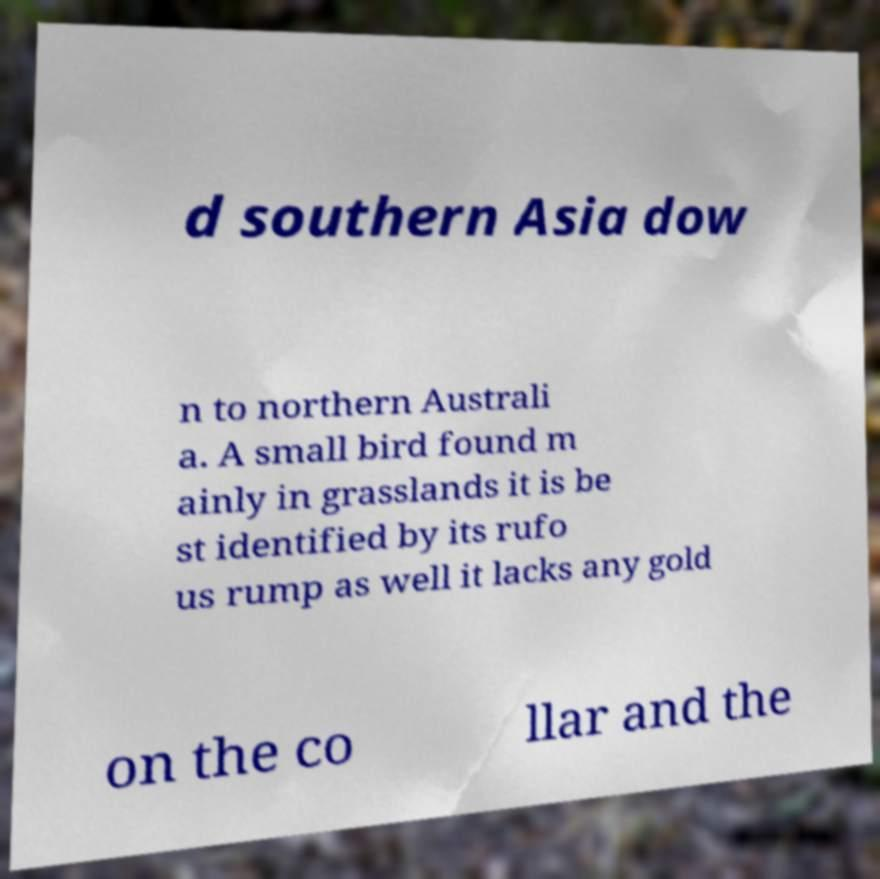Could you assist in decoding the text presented in this image and type it out clearly? d southern Asia dow n to northern Australi a. A small bird found m ainly in grasslands it is be st identified by its rufo us rump as well it lacks any gold on the co llar and the 